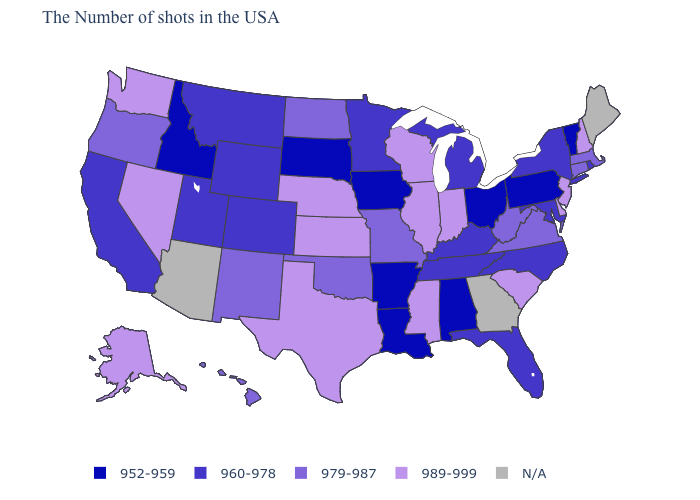Among the states that border Arkansas , which have the highest value?
Give a very brief answer. Mississippi, Texas. Which states have the highest value in the USA?
Concise answer only. New Hampshire, New Jersey, Delaware, South Carolina, Indiana, Wisconsin, Illinois, Mississippi, Kansas, Nebraska, Texas, Nevada, Washington, Alaska. Name the states that have a value in the range 960-978?
Answer briefly. Rhode Island, New York, Maryland, North Carolina, Florida, Michigan, Kentucky, Tennessee, Minnesota, Wyoming, Colorado, Utah, Montana, California. Name the states that have a value in the range N/A?
Be succinct. Maine, Georgia, Arizona. What is the value of Illinois?
Write a very short answer. 989-999. What is the lowest value in states that border Mississippi?
Write a very short answer. 952-959. Among the states that border Texas , which have the lowest value?
Concise answer only. Louisiana, Arkansas. Name the states that have a value in the range 989-999?
Be succinct. New Hampshire, New Jersey, Delaware, South Carolina, Indiana, Wisconsin, Illinois, Mississippi, Kansas, Nebraska, Texas, Nevada, Washington, Alaska. What is the value of Wisconsin?
Concise answer only. 989-999. Among the states that border Oklahoma , does Kansas have the highest value?
Answer briefly. Yes. Name the states that have a value in the range 952-959?
Concise answer only. Vermont, Pennsylvania, Ohio, Alabama, Louisiana, Arkansas, Iowa, South Dakota, Idaho. Does Pennsylvania have the lowest value in the Northeast?
Concise answer only. Yes. Does North Carolina have the lowest value in the USA?
Keep it brief. No. Does the map have missing data?
Concise answer only. Yes. 